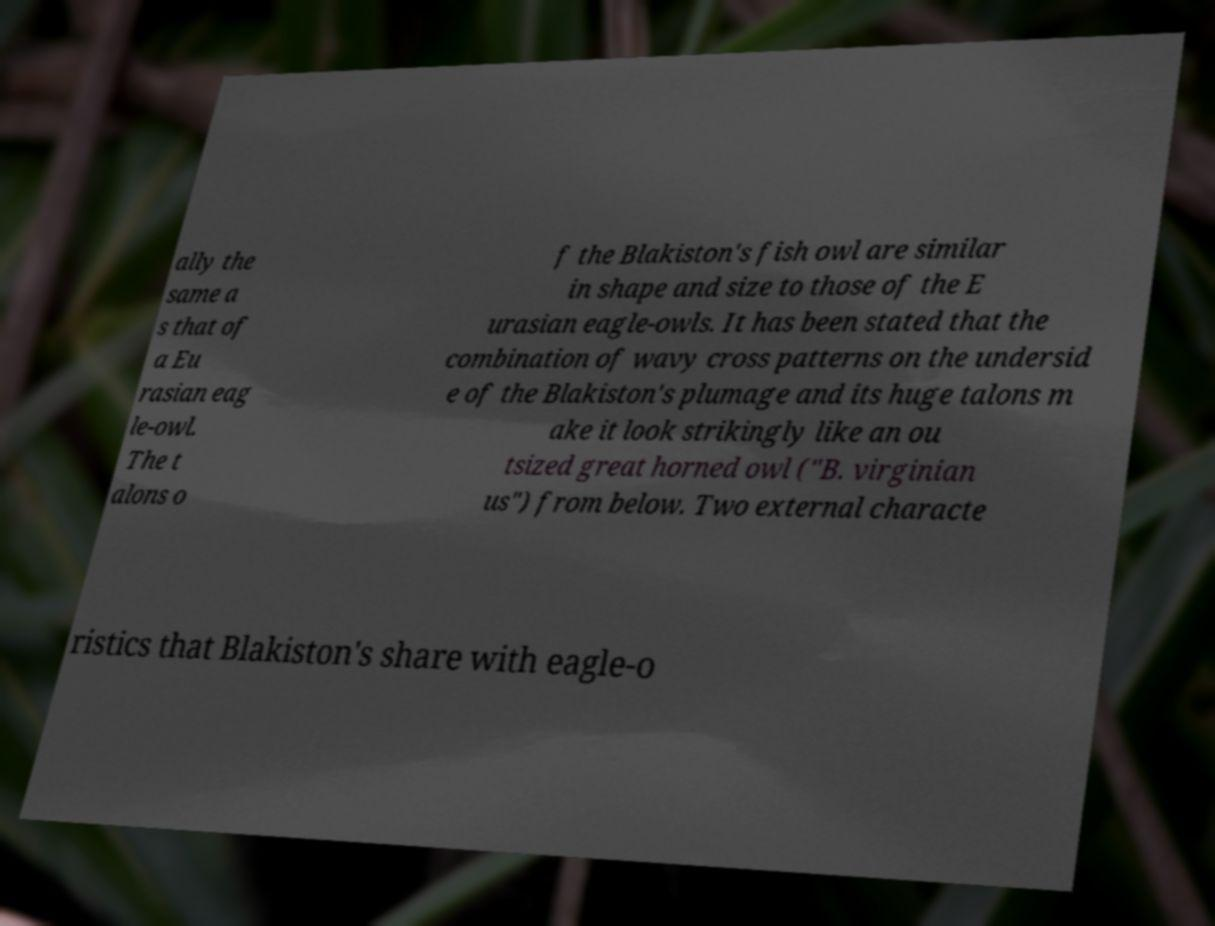Could you assist in decoding the text presented in this image and type it out clearly? ally the same a s that of a Eu rasian eag le-owl. The t alons o f the Blakiston's fish owl are similar in shape and size to those of the E urasian eagle-owls. It has been stated that the combination of wavy cross patterns on the undersid e of the Blakiston's plumage and its huge talons m ake it look strikingly like an ou tsized great horned owl ("B. virginian us") from below. Two external characte ristics that Blakiston's share with eagle-o 